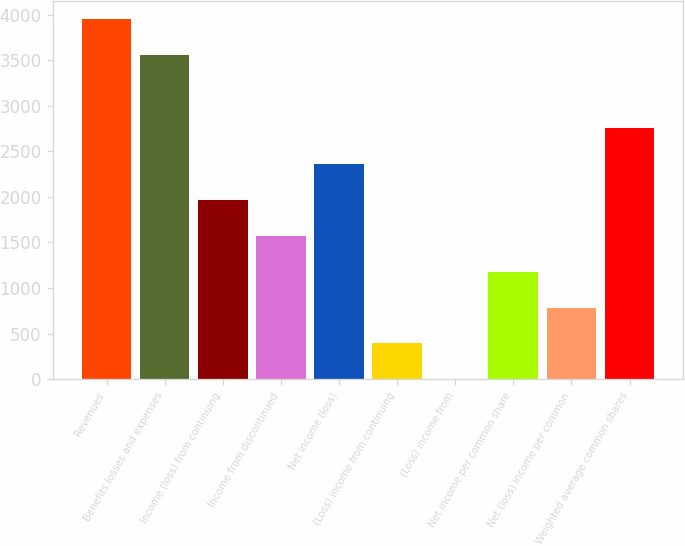Convert chart. <chart><loc_0><loc_0><loc_500><loc_500><bar_chart><fcel>Revenues<fcel>Benefits losses and expenses<fcel>Income (loss) from continuing<fcel>Income from discontinued<fcel>Net income (loss)<fcel>(Loss) income from continuing<fcel>(Loss) income from<fcel>Net income per common share<fcel>Net (loss) income per common<fcel>Weighted average common shares<nl><fcel>3948.99<fcel>3556<fcel>1965.01<fcel>1572.02<fcel>2358<fcel>393.05<fcel>0.06<fcel>1179.03<fcel>786.04<fcel>2750.99<nl></chart> 